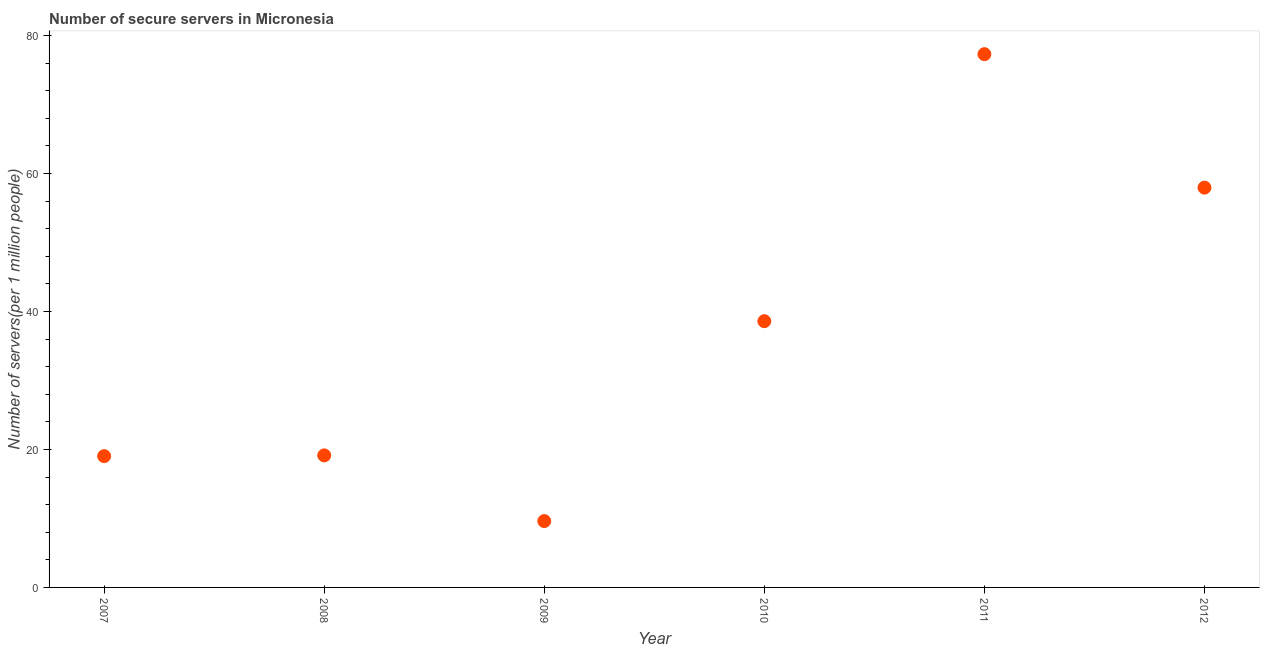What is the number of secure internet servers in 2008?
Provide a succinct answer. 19.14. Across all years, what is the maximum number of secure internet servers?
Keep it short and to the point. 77.31. Across all years, what is the minimum number of secure internet servers?
Keep it short and to the point. 9.62. In which year was the number of secure internet servers maximum?
Offer a terse response. 2011. In which year was the number of secure internet servers minimum?
Keep it short and to the point. 2009. What is the sum of the number of secure internet servers?
Offer a terse response. 221.67. What is the difference between the number of secure internet servers in 2008 and 2010?
Make the answer very short. -19.46. What is the average number of secure internet servers per year?
Your response must be concise. 36.95. What is the median number of secure internet servers?
Your answer should be very brief. 28.87. In how many years, is the number of secure internet servers greater than 40 ?
Make the answer very short. 2. What is the ratio of the number of secure internet servers in 2009 to that in 2012?
Offer a terse response. 0.17. Is the difference between the number of secure internet servers in 2011 and 2012 greater than the difference between any two years?
Offer a very short reply. No. What is the difference between the highest and the second highest number of secure internet servers?
Your response must be concise. 19.35. Is the sum of the number of secure internet servers in 2008 and 2012 greater than the maximum number of secure internet servers across all years?
Offer a very short reply. No. What is the difference between the highest and the lowest number of secure internet servers?
Offer a very short reply. 67.69. How many dotlines are there?
Provide a succinct answer. 1. How many years are there in the graph?
Provide a short and direct response. 6. Does the graph contain grids?
Offer a very short reply. No. What is the title of the graph?
Provide a succinct answer. Number of secure servers in Micronesia. What is the label or title of the Y-axis?
Your response must be concise. Number of servers(per 1 million people). What is the Number of servers(per 1 million people) in 2007?
Give a very brief answer. 19.03. What is the Number of servers(per 1 million people) in 2008?
Offer a terse response. 19.14. What is the Number of servers(per 1 million people) in 2009?
Provide a short and direct response. 9.62. What is the Number of servers(per 1 million people) in 2010?
Make the answer very short. 38.6. What is the Number of servers(per 1 million people) in 2011?
Provide a succinct answer. 77.31. What is the Number of servers(per 1 million people) in 2012?
Your answer should be compact. 57.96. What is the difference between the Number of servers(per 1 million people) in 2007 and 2008?
Your answer should be compact. -0.11. What is the difference between the Number of servers(per 1 million people) in 2007 and 2009?
Your answer should be very brief. 9.41. What is the difference between the Number of servers(per 1 million people) in 2007 and 2010?
Ensure brevity in your answer.  -19.57. What is the difference between the Number of servers(per 1 million people) in 2007 and 2011?
Your answer should be very brief. -58.28. What is the difference between the Number of servers(per 1 million people) in 2007 and 2012?
Offer a terse response. -38.93. What is the difference between the Number of servers(per 1 million people) in 2008 and 2009?
Keep it short and to the point. 9.52. What is the difference between the Number of servers(per 1 million people) in 2008 and 2010?
Provide a short and direct response. -19.46. What is the difference between the Number of servers(per 1 million people) in 2008 and 2011?
Your response must be concise. -58.17. What is the difference between the Number of servers(per 1 million people) in 2008 and 2012?
Provide a short and direct response. -38.82. What is the difference between the Number of servers(per 1 million people) in 2009 and 2010?
Your response must be concise. -28.98. What is the difference between the Number of servers(per 1 million people) in 2009 and 2011?
Make the answer very short. -67.69. What is the difference between the Number of servers(per 1 million people) in 2009 and 2012?
Provide a succinct answer. -48.34. What is the difference between the Number of servers(per 1 million people) in 2010 and 2011?
Your answer should be very brief. -38.71. What is the difference between the Number of servers(per 1 million people) in 2010 and 2012?
Your answer should be compact. -19.36. What is the difference between the Number of servers(per 1 million people) in 2011 and 2012?
Your response must be concise. 19.35. What is the ratio of the Number of servers(per 1 million people) in 2007 to that in 2009?
Give a very brief answer. 1.98. What is the ratio of the Number of servers(per 1 million people) in 2007 to that in 2010?
Provide a succinct answer. 0.49. What is the ratio of the Number of servers(per 1 million people) in 2007 to that in 2011?
Your answer should be compact. 0.25. What is the ratio of the Number of servers(per 1 million people) in 2007 to that in 2012?
Your answer should be compact. 0.33. What is the ratio of the Number of servers(per 1 million people) in 2008 to that in 2009?
Your response must be concise. 1.99. What is the ratio of the Number of servers(per 1 million people) in 2008 to that in 2010?
Keep it short and to the point. 0.5. What is the ratio of the Number of servers(per 1 million people) in 2008 to that in 2011?
Provide a short and direct response. 0.25. What is the ratio of the Number of servers(per 1 million people) in 2008 to that in 2012?
Give a very brief answer. 0.33. What is the ratio of the Number of servers(per 1 million people) in 2009 to that in 2010?
Keep it short and to the point. 0.25. What is the ratio of the Number of servers(per 1 million people) in 2009 to that in 2011?
Your answer should be very brief. 0.12. What is the ratio of the Number of servers(per 1 million people) in 2009 to that in 2012?
Ensure brevity in your answer.  0.17. What is the ratio of the Number of servers(per 1 million people) in 2010 to that in 2011?
Ensure brevity in your answer.  0.5. What is the ratio of the Number of servers(per 1 million people) in 2010 to that in 2012?
Your answer should be very brief. 0.67. What is the ratio of the Number of servers(per 1 million people) in 2011 to that in 2012?
Give a very brief answer. 1.33. 